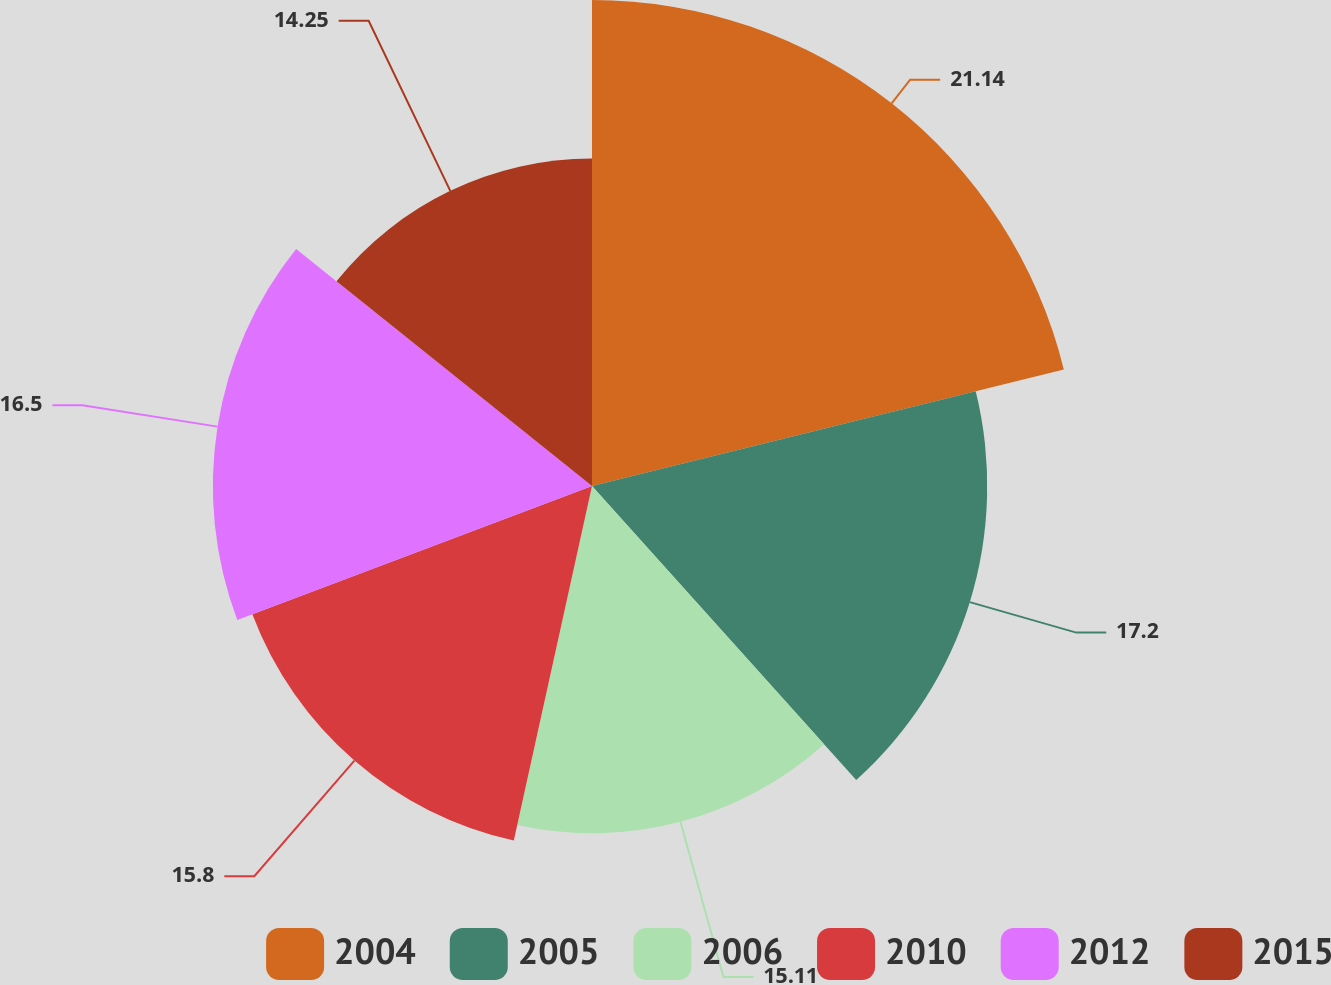Convert chart to OTSL. <chart><loc_0><loc_0><loc_500><loc_500><pie_chart><fcel>2004<fcel>2005<fcel>2006<fcel>2010<fcel>2012<fcel>2015<nl><fcel>21.15%<fcel>17.2%<fcel>15.11%<fcel>15.8%<fcel>16.5%<fcel>14.25%<nl></chart> 